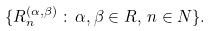<formula> <loc_0><loc_0><loc_500><loc_500>\{ R _ { n } ^ { ( \alpha , \beta ) } \, \colon \, \alpha , \beta \in R , \, n \in N \} .</formula> 